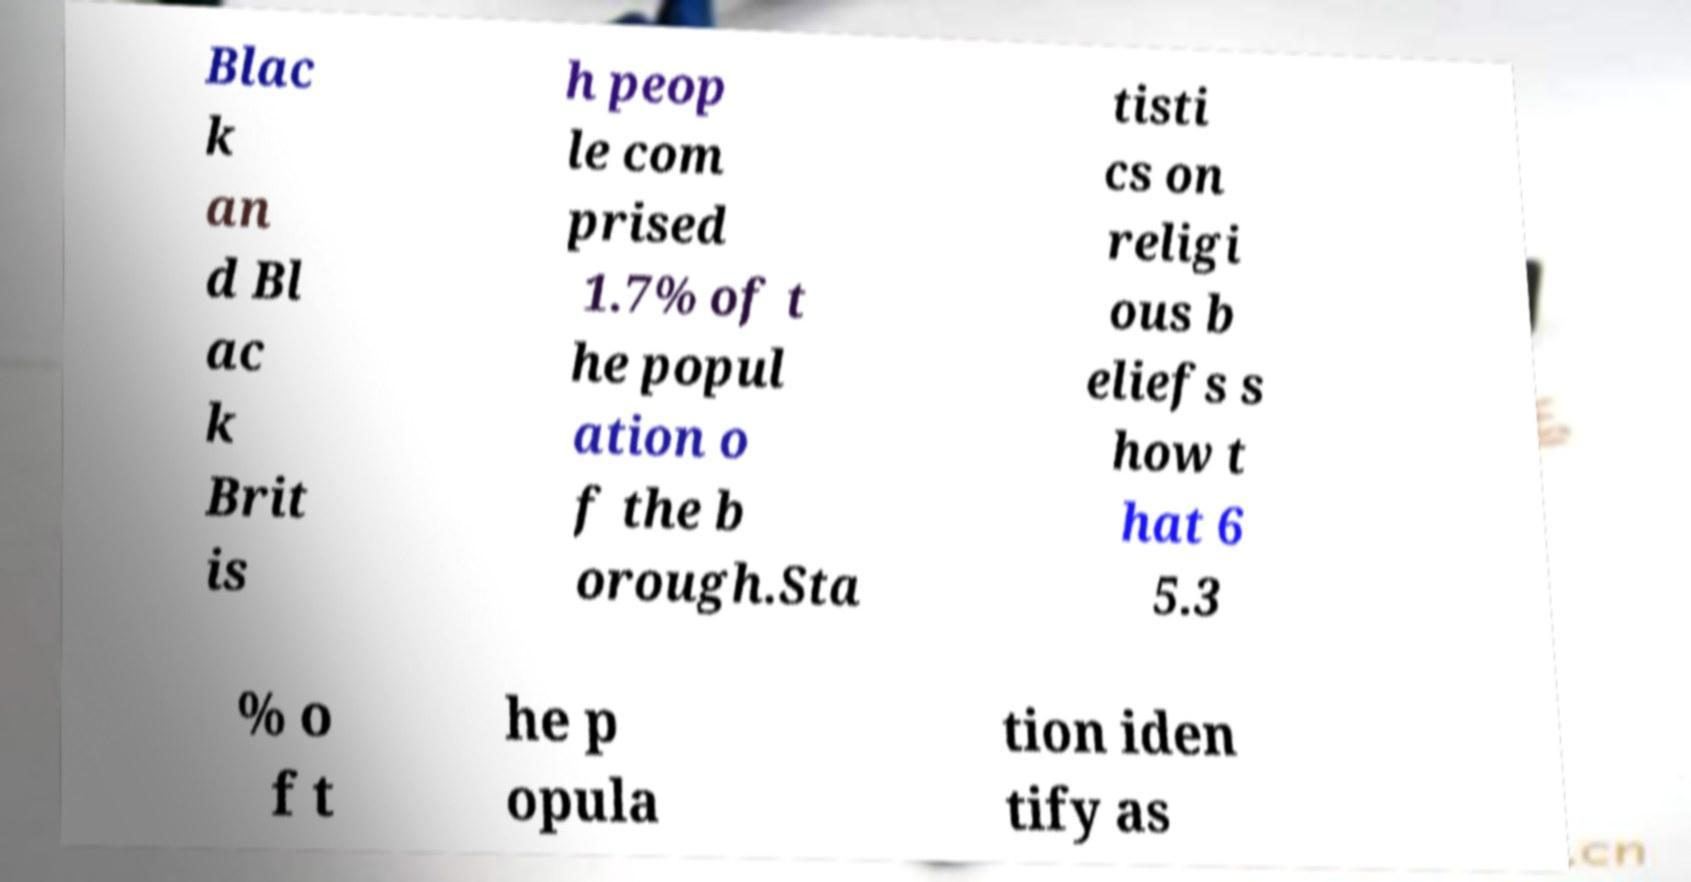What messages or text are displayed in this image? I need them in a readable, typed format. Blac k an d Bl ac k Brit is h peop le com prised 1.7% of t he popul ation o f the b orough.Sta tisti cs on religi ous b eliefs s how t hat 6 5.3 % o f t he p opula tion iden tify as 